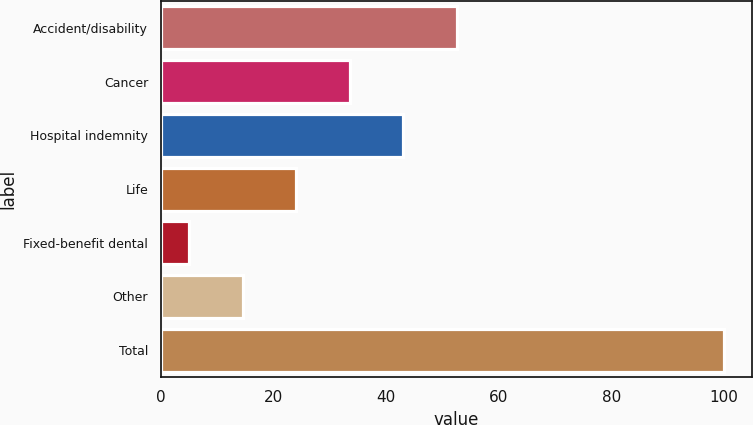Convert chart to OTSL. <chart><loc_0><loc_0><loc_500><loc_500><bar_chart><fcel>Accident/disability<fcel>Cancer<fcel>Hospital indemnity<fcel>Life<fcel>Fixed-benefit dental<fcel>Other<fcel>Total<nl><fcel>52.5<fcel>33.5<fcel>43<fcel>24<fcel>5<fcel>14.5<fcel>100<nl></chart> 